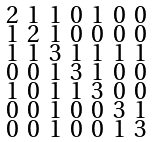<formula> <loc_0><loc_0><loc_500><loc_500>\begin{smallmatrix} 2 & 1 & 1 & 0 & 1 & 0 & 0 \\ 1 & 2 & 1 & 0 & 0 & 0 & 0 \\ 1 & 1 & 3 & 1 & 1 & 1 & 1 \\ 0 & 0 & 1 & 3 & 1 & 0 & 0 \\ 1 & 0 & 1 & 1 & 3 & 0 & 0 \\ 0 & 0 & 1 & 0 & 0 & 3 & 1 \\ 0 & 0 & 1 & 0 & 0 & 1 & 3 \end{smallmatrix}</formula> 